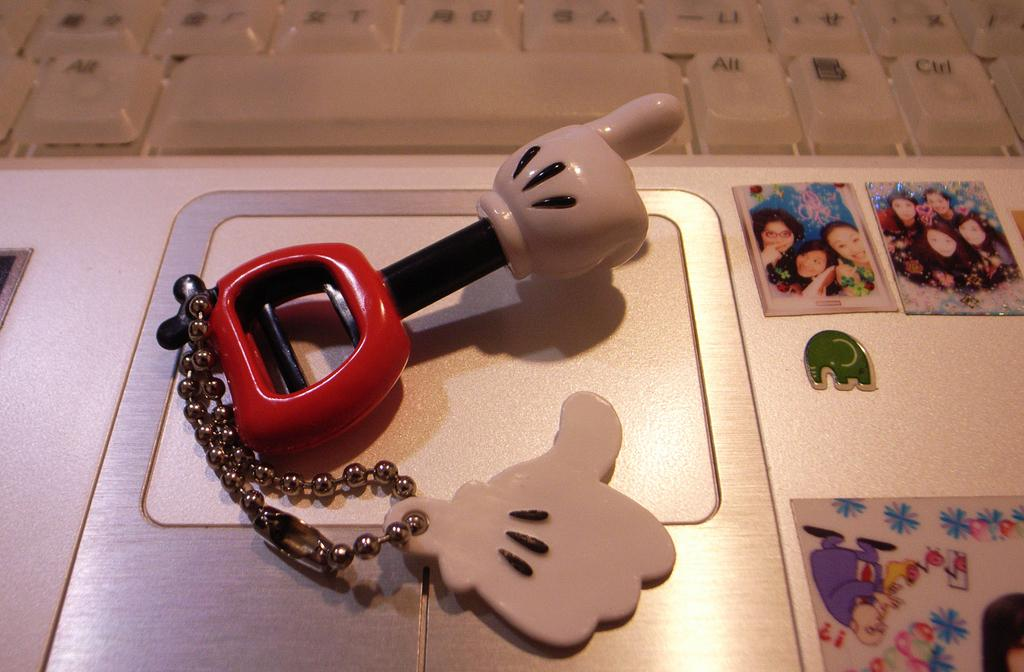What electronic device is visible in the image? There is a laptop in the image. What is displayed on the laptop screen? Photos are displayed on the laptop screen. What is placed on the laptop's mouse? There is an object placed on the laptop's mouse. What type of channel is visible on the laptop screen? There is no channel visible on the laptop screen; it displays photos. 